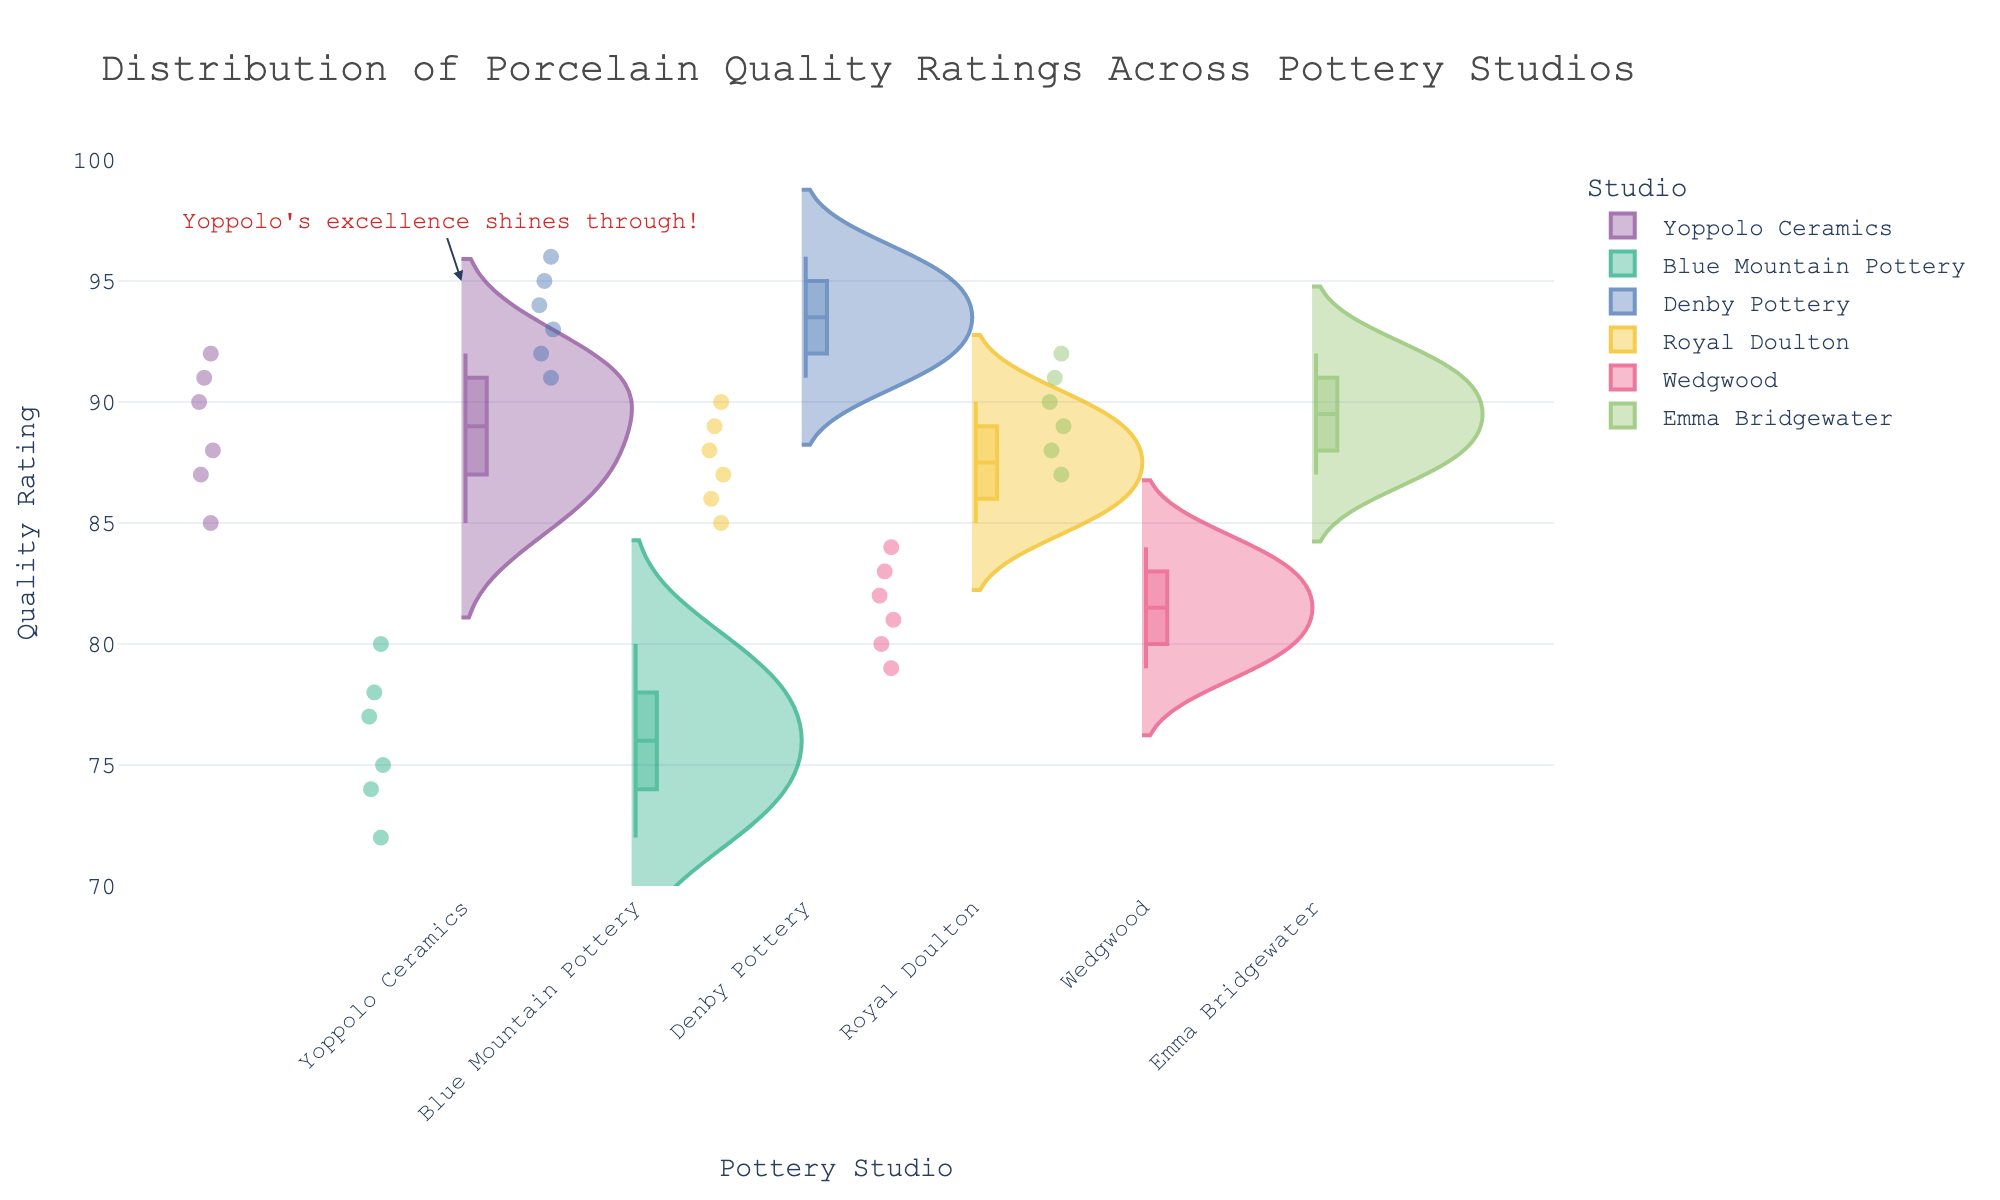What's the title of the figure? The title is usually located at the top of the figure and it's meant to describe the main topic of the chart.
Answer: Distribution of Porcelain Quality Ratings Across Pottery Studios Which studio has the highest median quality rating? The box component of the violin plot shows the median value. Comparing the box positions for all studios reveals that Denby Pottery has the highest median rating.
Answer: Denby Pottery Which studio has the widest range of quality ratings? The range of the violin plot for each studio indicates the spread of the data. Observing the plots, Blue Mountain Pottery has the widest range from 72 to 80.
Answer: Blue Mountain Pottery How does the quality rating of Yoppolo Ceramics compare with Royal Doulton? Comparing the violin plots of Yoppolo Ceramics and Royal Doulton shows that Yoppolo Ceramics has a higher range and median quality rating.
Answer: Yoppolo Ceramics has higher ratings What is the approximate range of quality ratings for Emma Bridgewater? The range in the violin plot for Emma Bridgewater spans from the lowest to highest points in the vertical space. It ranges approximately from 87 to 92.
Answer: 87 to 92 Which studios have quality ratings that mostly overlap? Observing the overlap areas in the violin plots, Royal Doulton and Yoppolo Ceramics have the most significant overlapping quality ratings.
Answer: Royal Doulton and Yoppolo Ceramics What does the annotation on the figure for Yoppolo Ceramics say? The annotation for Yoppolo Ceramics is added for a personal touch and reads "Yoppolo's excellence shines through!".
Answer: Yoppolo's excellence shines through! Compare the average ratings of Blue Mountain Pottery and Wedgwood. To find the average, sum the ratings of each studio and divide by the number of data points. Blue Mountain Pottery: (72+77+80+75+78+74)/6 = 76; Wedgwood: (80+82+79+81+83+84)/6 = 81.5
Answer: Wedgwood Which studio has the lowest single quality rating and what is that rating? The lowest rating from the violin plots can be seen in the range for Blue Mountain Pottery, which is 72.
Answer: Blue Mountain Pottery, 72 How many quality ratings are plotted for Yoppolo Ceramics? The number of data points or dots within the Yoppolo Ceramics area of the violin plot indicates the number of quality ratings plotted, which is 6.
Answer: 6 